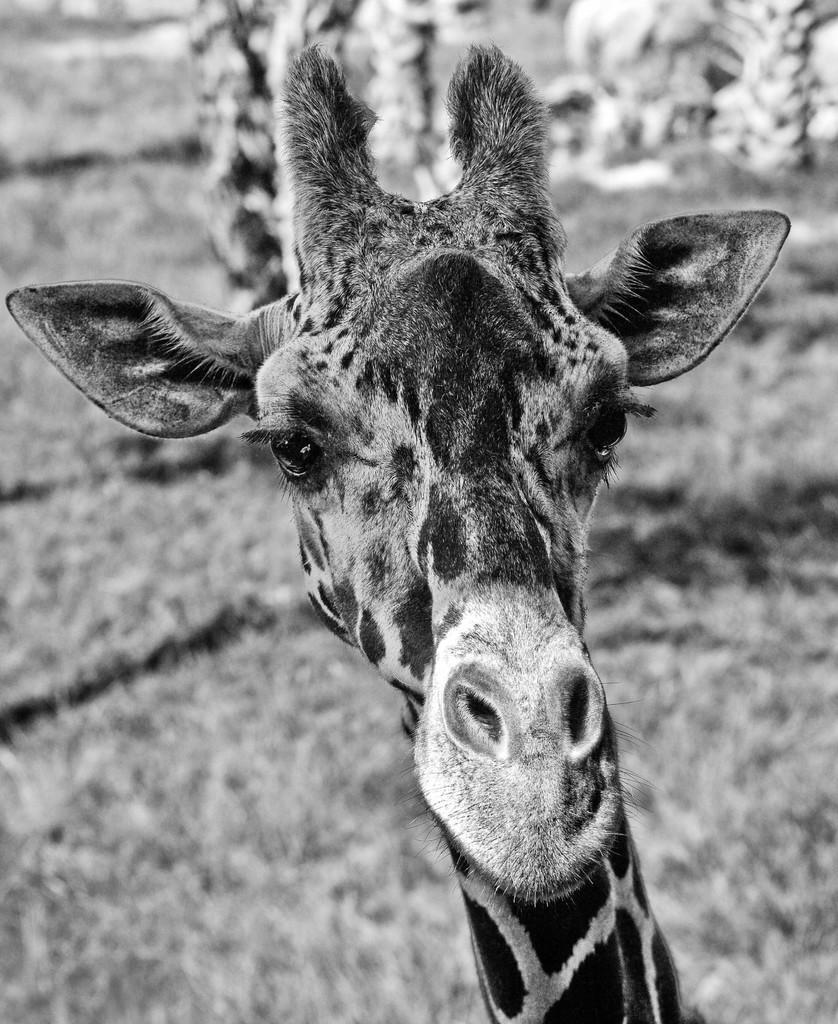Could you give a brief overview of what you see in this image? This is a black and white image of a giraffe. In the background it is blurred. 